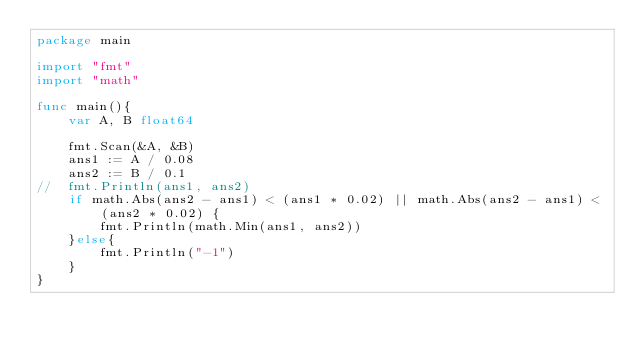Convert code to text. <code><loc_0><loc_0><loc_500><loc_500><_Go_>package main

import "fmt"
import "math"

func main(){
	var A, B float64

	fmt.Scan(&A, &B)
	ans1 := A / 0.08
	ans2 := B / 0.1
//	fmt.Println(ans1, ans2)
	if math.Abs(ans2 - ans1) < (ans1 * 0.02) || math.Abs(ans2 - ans1) < (ans2 * 0.02) {
		fmt.Println(math.Min(ans1, ans2))
	}else{
		fmt.Println("-1")
	}
}</code> 